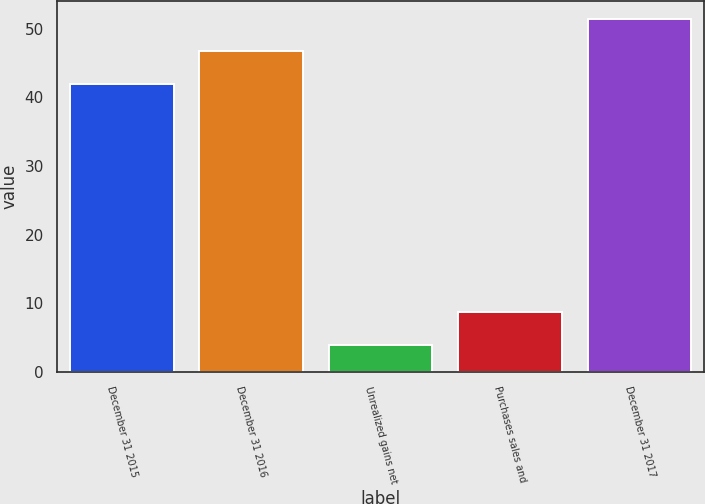Convert chart to OTSL. <chart><loc_0><loc_0><loc_500><loc_500><bar_chart><fcel>December 31 2015<fcel>December 31 2016<fcel>Unrealized gains net<fcel>Purchases sales and<fcel>December 31 2017<nl><fcel>42<fcel>46.7<fcel>4<fcel>8.7<fcel>51.4<nl></chart> 